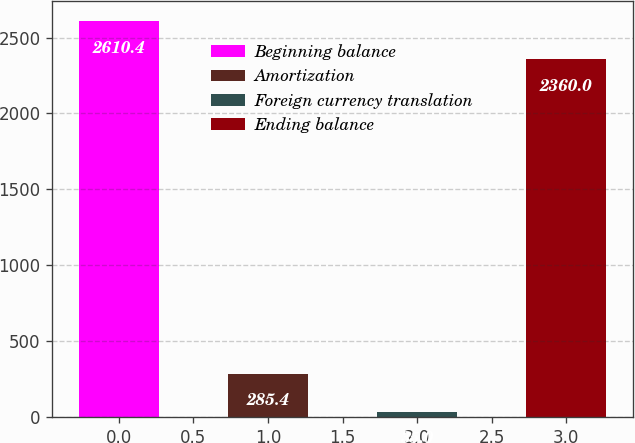Convert chart. <chart><loc_0><loc_0><loc_500><loc_500><bar_chart><fcel>Beginning balance<fcel>Amortization<fcel>Foreign currency translation<fcel>Ending balance<nl><fcel>2610.4<fcel>285.4<fcel>35<fcel>2360<nl></chart> 